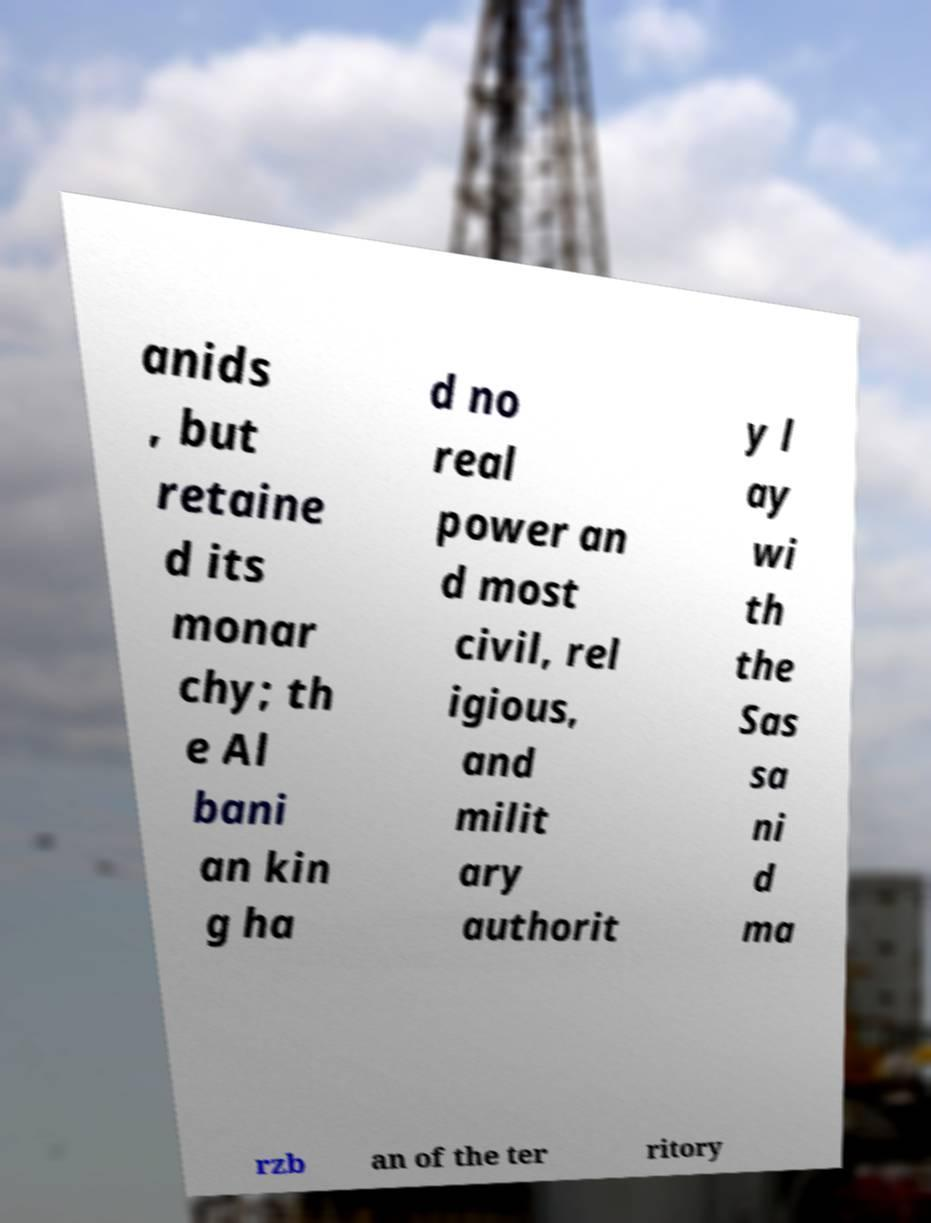Can you accurately transcribe the text from the provided image for me? anids , but retaine d its monar chy; th e Al bani an kin g ha d no real power an d most civil, rel igious, and milit ary authorit y l ay wi th the Sas sa ni d ma rzb an of the ter ritory 